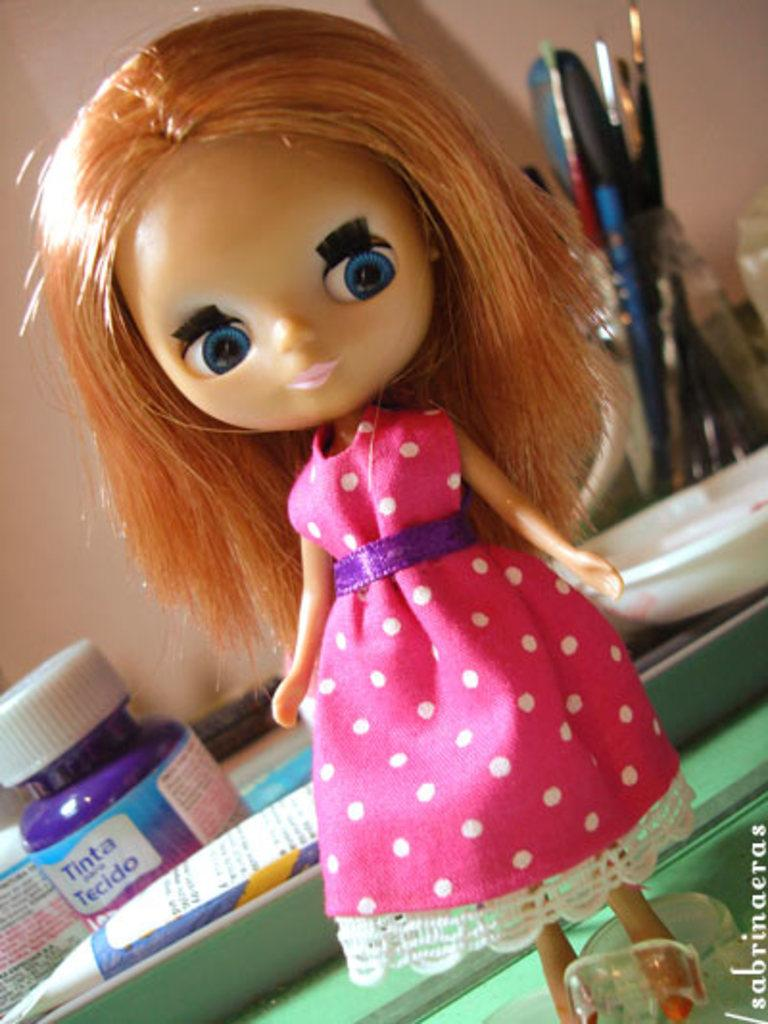What is the main subject in the center of the image? There is a doll in the center of the image. What can be seen in the background of the image? There are pens, papers, and a wall in the background of the image. What color is the silver in the image? There is no silver present in the image. How does the doll answer the questions in the image? The doll is an inanimate object and cannot answer questions. 